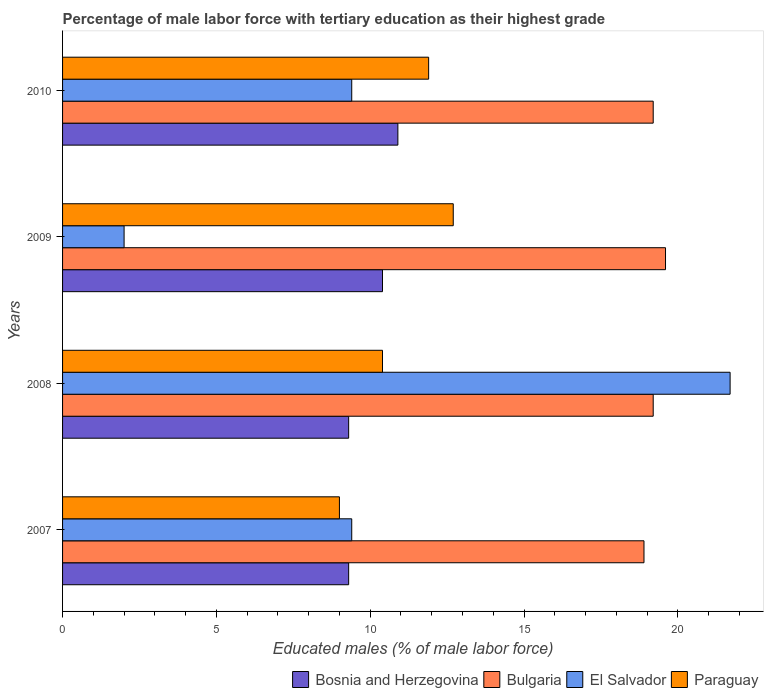How many bars are there on the 2nd tick from the top?
Offer a terse response. 4. How many bars are there on the 4th tick from the bottom?
Offer a terse response. 4. What is the label of the 3rd group of bars from the top?
Make the answer very short. 2008. What is the percentage of male labor force with tertiary education in Bosnia and Herzegovina in 2010?
Your answer should be compact. 10.9. Across all years, what is the maximum percentage of male labor force with tertiary education in El Salvador?
Provide a succinct answer. 21.7. Across all years, what is the minimum percentage of male labor force with tertiary education in Bulgaria?
Keep it short and to the point. 18.9. In which year was the percentage of male labor force with tertiary education in Bosnia and Herzegovina maximum?
Provide a short and direct response. 2010. In which year was the percentage of male labor force with tertiary education in Bosnia and Herzegovina minimum?
Ensure brevity in your answer.  2007. What is the total percentage of male labor force with tertiary education in El Salvador in the graph?
Keep it short and to the point. 42.5. What is the difference between the percentage of male labor force with tertiary education in Bulgaria in 2007 and that in 2010?
Make the answer very short. -0.3. What is the difference between the percentage of male labor force with tertiary education in Paraguay in 2009 and the percentage of male labor force with tertiary education in Bosnia and Herzegovina in 2007?
Your answer should be very brief. 3.4. What is the average percentage of male labor force with tertiary education in Bulgaria per year?
Provide a succinct answer. 19.23. In the year 2008, what is the difference between the percentage of male labor force with tertiary education in Bulgaria and percentage of male labor force with tertiary education in Bosnia and Herzegovina?
Your answer should be compact. 9.9. In how many years, is the percentage of male labor force with tertiary education in El Salvador greater than 12 %?
Provide a succinct answer. 1. What is the ratio of the percentage of male labor force with tertiary education in Paraguay in 2008 to that in 2010?
Keep it short and to the point. 0.87. Is the percentage of male labor force with tertiary education in Bosnia and Herzegovina in 2009 less than that in 2010?
Offer a terse response. Yes. Is the difference between the percentage of male labor force with tertiary education in Bulgaria in 2007 and 2010 greater than the difference between the percentage of male labor force with tertiary education in Bosnia and Herzegovina in 2007 and 2010?
Give a very brief answer. Yes. What is the difference between the highest and the second highest percentage of male labor force with tertiary education in El Salvador?
Provide a short and direct response. 12.3. What is the difference between the highest and the lowest percentage of male labor force with tertiary education in Bosnia and Herzegovina?
Offer a very short reply. 1.6. In how many years, is the percentage of male labor force with tertiary education in Bulgaria greater than the average percentage of male labor force with tertiary education in Bulgaria taken over all years?
Make the answer very short. 1. Is it the case that in every year, the sum of the percentage of male labor force with tertiary education in El Salvador and percentage of male labor force with tertiary education in Paraguay is greater than the sum of percentage of male labor force with tertiary education in Bosnia and Herzegovina and percentage of male labor force with tertiary education in Bulgaria?
Provide a short and direct response. No. What does the 2nd bar from the bottom in 2009 represents?
Provide a succinct answer. Bulgaria. Are all the bars in the graph horizontal?
Provide a short and direct response. Yes. How many years are there in the graph?
Offer a very short reply. 4. Does the graph contain any zero values?
Offer a very short reply. No. Does the graph contain grids?
Give a very brief answer. No. Where does the legend appear in the graph?
Offer a very short reply. Bottom right. How many legend labels are there?
Your answer should be compact. 4. What is the title of the graph?
Make the answer very short. Percentage of male labor force with tertiary education as their highest grade. Does "Italy" appear as one of the legend labels in the graph?
Keep it short and to the point. No. What is the label or title of the X-axis?
Offer a very short reply. Educated males (% of male labor force). What is the Educated males (% of male labor force) of Bosnia and Herzegovina in 2007?
Offer a very short reply. 9.3. What is the Educated males (% of male labor force) of Bulgaria in 2007?
Provide a short and direct response. 18.9. What is the Educated males (% of male labor force) in El Salvador in 2007?
Provide a succinct answer. 9.4. What is the Educated males (% of male labor force) in Bosnia and Herzegovina in 2008?
Your answer should be compact. 9.3. What is the Educated males (% of male labor force) in Bulgaria in 2008?
Give a very brief answer. 19.2. What is the Educated males (% of male labor force) in El Salvador in 2008?
Offer a terse response. 21.7. What is the Educated males (% of male labor force) in Paraguay in 2008?
Ensure brevity in your answer.  10.4. What is the Educated males (% of male labor force) in Bosnia and Herzegovina in 2009?
Your answer should be compact. 10.4. What is the Educated males (% of male labor force) in Bulgaria in 2009?
Ensure brevity in your answer.  19.6. What is the Educated males (% of male labor force) in El Salvador in 2009?
Provide a succinct answer. 2. What is the Educated males (% of male labor force) in Paraguay in 2009?
Keep it short and to the point. 12.7. What is the Educated males (% of male labor force) of Bosnia and Herzegovina in 2010?
Keep it short and to the point. 10.9. What is the Educated males (% of male labor force) in Bulgaria in 2010?
Keep it short and to the point. 19.2. What is the Educated males (% of male labor force) in El Salvador in 2010?
Your answer should be very brief. 9.4. What is the Educated males (% of male labor force) of Paraguay in 2010?
Ensure brevity in your answer.  11.9. Across all years, what is the maximum Educated males (% of male labor force) in Bosnia and Herzegovina?
Offer a very short reply. 10.9. Across all years, what is the maximum Educated males (% of male labor force) in Bulgaria?
Offer a very short reply. 19.6. Across all years, what is the maximum Educated males (% of male labor force) of El Salvador?
Make the answer very short. 21.7. Across all years, what is the maximum Educated males (% of male labor force) in Paraguay?
Offer a very short reply. 12.7. Across all years, what is the minimum Educated males (% of male labor force) of Bosnia and Herzegovina?
Make the answer very short. 9.3. Across all years, what is the minimum Educated males (% of male labor force) in Bulgaria?
Offer a terse response. 18.9. Across all years, what is the minimum Educated males (% of male labor force) in El Salvador?
Provide a succinct answer. 2. Across all years, what is the minimum Educated males (% of male labor force) in Paraguay?
Provide a succinct answer. 9. What is the total Educated males (% of male labor force) in Bosnia and Herzegovina in the graph?
Provide a short and direct response. 39.9. What is the total Educated males (% of male labor force) in Bulgaria in the graph?
Ensure brevity in your answer.  76.9. What is the total Educated males (% of male labor force) of El Salvador in the graph?
Your answer should be compact. 42.5. What is the total Educated males (% of male labor force) of Paraguay in the graph?
Your answer should be compact. 44. What is the difference between the Educated males (% of male labor force) in Paraguay in 2007 and that in 2009?
Offer a terse response. -3.7. What is the difference between the Educated males (% of male labor force) in Bosnia and Herzegovina in 2007 and that in 2010?
Make the answer very short. -1.6. What is the difference between the Educated males (% of male labor force) in Paraguay in 2007 and that in 2010?
Make the answer very short. -2.9. What is the difference between the Educated males (% of male labor force) of Bulgaria in 2008 and that in 2009?
Provide a short and direct response. -0.4. What is the difference between the Educated males (% of male labor force) in Bulgaria in 2008 and that in 2010?
Ensure brevity in your answer.  0. What is the difference between the Educated males (% of male labor force) in Paraguay in 2008 and that in 2010?
Offer a very short reply. -1.5. What is the difference between the Educated males (% of male labor force) of Bulgaria in 2009 and that in 2010?
Provide a succinct answer. 0.4. What is the difference between the Educated males (% of male labor force) in Paraguay in 2009 and that in 2010?
Your response must be concise. 0.8. What is the difference between the Educated males (% of male labor force) of Bosnia and Herzegovina in 2007 and the Educated males (% of male labor force) of Bulgaria in 2008?
Your answer should be compact. -9.9. What is the difference between the Educated males (% of male labor force) of Bosnia and Herzegovina in 2007 and the Educated males (% of male labor force) of El Salvador in 2008?
Give a very brief answer. -12.4. What is the difference between the Educated males (% of male labor force) in Bulgaria in 2007 and the Educated males (% of male labor force) in Paraguay in 2008?
Offer a terse response. 8.5. What is the difference between the Educated males (% of male labor force) of Bulgaria in 2007 and the Educated males (% of male labor force) of El Salvador in 2009?
Your answer should be compact. 16.9. What is the difference between the Educated males (% of male labor force) in Bulgaria in 2007 and the Educated males (% of male labor force) in Paraguay in 2009?
Your response must be concise. 6.2. What is the difference between the Educated males (% of male labor force) in El Salvador in 2007 and the Educated males (% of male labor force) in Paraguay in 2009?
Provide a short and direct response. -3.3. What is the difference between the Educated males (% of male labor force) in Bosnia and Herzegovina in 2007 and the Educated males (% of male labor force) in Paraguay in 2010?
Provide a short and direct response. -2.6. What is the difference between the Educated males (% of male labor force) of Bulgaria in 2007 and the Educated males (% of male labor force) of Paraguay in 2010?
Keep it short and to the point. 7. What is the difference between the Educated males (% of male labor force) in Bosnia and Herzegovina in 2008 and the Educated males (% of male labor force) in Bulgaria in 2009?
Ensure brevity in your answer.  -10.3. What is the difference between the Educated males (% of male labor force) of Bosnia and Herzegovina in 2008 and the Educated males (% of male labor force) of El Salvador in 2009?
Offer a terse response. 7.3. What is the difference between the Educated males (% of male labor force) of Bosnia and Herzegovina in 2008 and the Educated males (% of male labor force) of Paraguay in 2009?
Offer a very short reply. -3.4. What is the difference between the Educated males (% of male labor force) in Bulgaria in 2008 and the Educated males (% of male labor force) in Paraguay in 2009?
Keep it short and to the point. 6.5. What is the difference between the Educated males (% of male labor force) of Bosnia and Herzegovina in 2008 and the Educated males (% of male labor force) of Bulgaria in 2010?
Your answer should be compact. -9.9. What is the difference between the Educated males (% of male labor force) in Bosnia and Herzegovina in 2008 and the Educated males (% of male labor force) in Paraguay in 2010?
Ensure brevity in your answer.  -2.6. What is the difference between the Educated males (% of male labor force) in Bulgaria in 2008 and the Educated males (% of male labor force) in Paraguay in 2010?
Provide a short and direct response. 7.3. What is the difference between the Educated males (% of male labor force) of Bosnia and Herzegovina in 2009 and the Educated males (% of male labor force) of Bulgaria in 2010?
Your response must be concise. -8.8. What is the difference between the Educated males (% of male labor force) in Bosnia and Herzegovina in 2009 and the Educated males (% of male labor force) in El Salvador in 2010?
Your answer should be compact. 1. What is the difference between the Educated males (% of male labor force) of Bulgaria in 2009 and the Educated males (% of male labor force) of El Salvador in 2010?
Your response must be concise. 10.2. What is the difference between the Educated males (% of male labor force) in Bulgaria in 2009 and the Educated males (% of male labor force) in Paraguay in 2010?
Your answer should be very brief. 7.7. What is the average Educated males (% of male labor force) in Bosnia and Herzegovina per year?
Ensure brevity in your answer.  9.97. What is the average Educated males (% of male labor force) of Bulgaria per year?
Keep it short and to the point. 19.23. What is the average Educated males (% of male labor force) in El Salvador per year?
Provide a short and direct response. 10.62. What is the average Educated males (% of male labor force) of Paraguay per year?
Make the answer very short. 11. In the year 2007, what is the difference between the Educated males (% of male labor force) of Bosnia and Herzegovina and Educated males (% of male labor force) of Paraguay?
Your response must be concise. 0.3. In the year 2007, what is the difference between the Educated males (% of male labor force) in El Salvador and Educated males (% of male labor force) in Paraguay?
Your answer should be very brief. 0.4. In the year 2008, what is the difference between the Educated males (% of male labor force) in Bosnia and Herzegovina and Educated males (% of male labor force) in El Salvador?
Keep it short and to the point. -12.4. In the year 2008, what is the difference between the Educated males (% of male labor force) of Bulgaria and Educated males (% of male labor force) of Paraguay?
Your answer should be very brief. 8.8. In the year 2008, what is the difference between the Educated males (% of male labor force) of El Salvador and Educated males (% of male labor force) of Paraguay?
Your answer should be compact. 11.3. In the year 2009, what is the difference between the Educated males (% of male labor force) of Bosnia and Herzegovina and Educated males (% of male labor force) of Paraguay?
Give a very brief answer. -2.3. In the year 2009, what is the difference between the Educated males (% of male labor force) of El Salvador and Educated males (% of male labor force) of Paraguay?
Provide a succinct answer. -10.7. In the year 2010, what is the difference between the Educated males (% of male labor force) of Bosnia and Herzegovina and Educated males (% of male labor force) of Bulgaria?
Offer a terse response. -8.3. In the year 2010, what is the difference between the Educated males (% of male labor force) in Bosnia and Herzegovina and Educated males (% of male labor force) in El Salvador?
Keep it short and to the point. 1.5. In the year 2010, what is the difference between the Educated males (% of male labor force) in Bulgaria and Educated males (% of male labor force) in El Salvador?
Your answer should be compact. 9.8. In the year 2010, what is the difference between the Educated males (% of male labor force) of Bulgaria and Educated males (% of male labor force) of Paraguay?
Give a very brief answer. 7.3. In the year 2010, what is the difference between the Educated males (% of male labor force) in El Salvador and Educated males (% of male labor force) in Paraguay?
Your answer should be compact. -2.5. What is the ratio of the Educated males (% of male labor force) in Bulgaria in 2007 to that in 2008?
Your answer should be compact. 0.98. What is the ratio of the Educated males (% of male labor force) in El Salvador in 2007 to that in 2008?
Offer a terse response. 0.43. What is the ratio of the Educated males (% of male labor force) of Paraguay in 2007 to that in 2008?
Keep it short and to the point. 0.87. What is the ratio of the Educated males (% of male labor force) in Bosnia and Herzegovina in 2007 to that in 2009?
Keep it short and to the point. 0.89. What is the ratio of the Educated males (% of male labor force) in Bulgaria in 2007 to that in 2009?
Give a very brief answer. 0.96. What is the ratio of the Educated males (% of male labor force) in El Salvador in 2007 to that in 2009?
Offer a very short reply. 4.7. What is the ratio of the Educated males (% of male labor force) in Paraguay in 2007 to that in 2009?
Offer a very short reply. 0.71. What is the ratio of the Educated males (% of male labor force) in Bosnia and Herzegovina in 2007 to that in 2010?
Your answer should be very brief. 0.85. What is the ratio of the Educated males (% of male labor force) in Bulgaria in 2007 to that in 2010?
Provide a succinct answer. 0.98. What is the ratio of the Educated males (% of male labor force) in El Salvador in 2007 to that in 2010?
Provide a succinct answer. 1. What is the ratio of the Educated males (% of male labor force) of Paraguay in 2007 to that in 2010?
Provide a short and direct response. 0.76. What is the ratio of the Educated males (% of male labor force) in Bosnia and Herzegovina in 2008 to that in 2009?
Provide a short and direct response. 0.89. What is the ratio of the Educated males (% of male labor force) in Bulgaria in 2008 to that in 2009?
Your answer should be compact. 0.98. What is the ratio of the Educated males (% of male labor force) of El Salvador in 2008 to that in 2009?
Offer a terse response. 10.85. What is the ratio of the Educated males (% of male labor force) in Paraguay in 2008 to that in 2009?
Your response must be concise. 0.82. What is the ratio of the Educated males (% of male labor force) of Bosnia and Herzegovina in 2008 to that in 2010?
Give a very brief answer. 0.85. What is the ratio of the Educated males (% of male labor force) of Bulgaria in 2008 to that in 2010?
Offer a very short reply. 1. What is the ratio of the Educated males (% of male labor force) in El Salvador in 2008 to that in 2010?
Offer a very short reply. 2.31. What is the ratio of the Educated males (% of male labor force) in Paraguay in 2008 to that in 2010?
Make the answer very short. 0.87. What is the ratio of the Educated males (% of male labor force) of Bosnia and Herzegovina in 2009 to that in 2010?
Give a very brief answer. 0.95. What is the ratio of the Educated males (% of male labor force) in Bulgaria in 2009 to that in 2010?
Your answer should be compact. 1.02. What is the ratio of the Educated males (% of male labor force) in El Salvador in 2009 to that in 2010?
Offer a very short reply. 0.21. What is the ratio of the Educated males (% of male labor force) of Paraguay in 2009 to that in 2010?
Your answer should be very brief. 1.07. What is the difference between the highest and the second highest Educated males (% of male labor force) of Bosnia and Herzegovina?
Offer a very short reply. 0.5. What is the difference between the highest and the second highest Educated males (% of male labor force) of Paraguay?
Give a very brief answer. 0.8. What is the difference between the highest and the lowest Educated males (% of male labor force) in El Salvador?
Keep it short and to the point. 19.7. What is the difference between the highest and the lowest Educated males (% of male labor force) of Paraguay?
Your answer should be very brief. 3.7. 